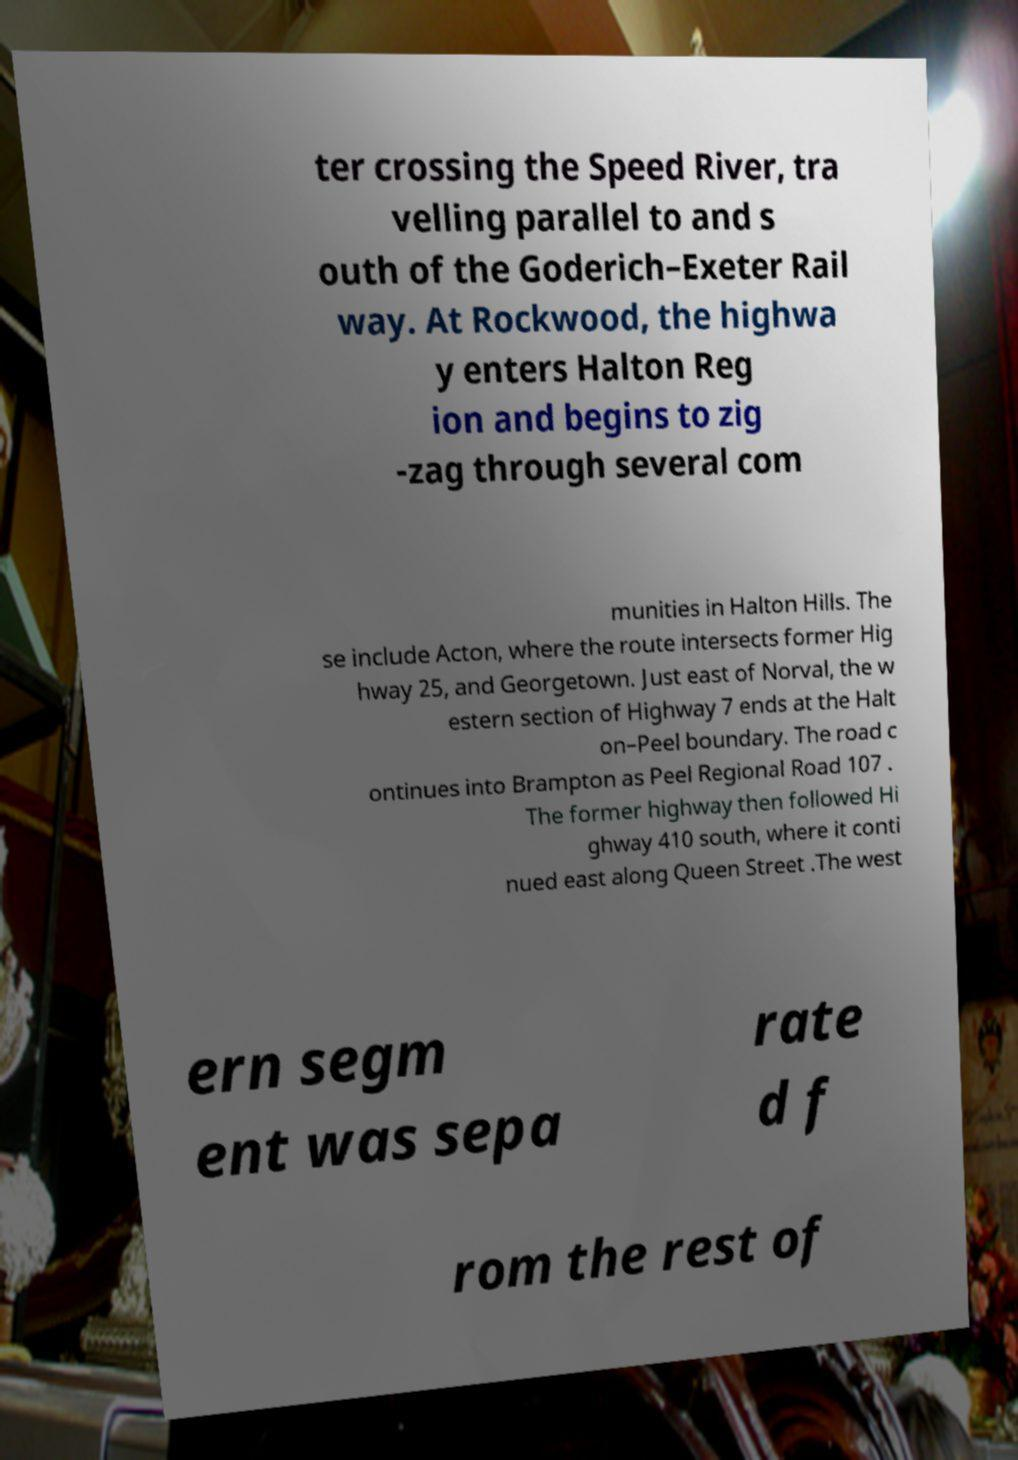Please identify and transcribe the text found in this image. ter crossing the Speed River, tra velling parallel to and s outh of the Goderich–Exeter Rail way. At Rockwood, the highwa y enters Halton Reg ion and begins to zig -zag through several com munities in Halton Hills. The se include Acton, where the route intersects former Hig hway 25, and Georgetown. Just east of Norval, the w estern section of Highway 7 ends at the Halt on–Peel boundary. The road c ontinues into Brampton as Peel Regional Road 107 . The former highway then followed Hi ghway 410 south, where it conti nued east along Queen Street .The west ern segm ent was sepa rate d f rom the rest of 